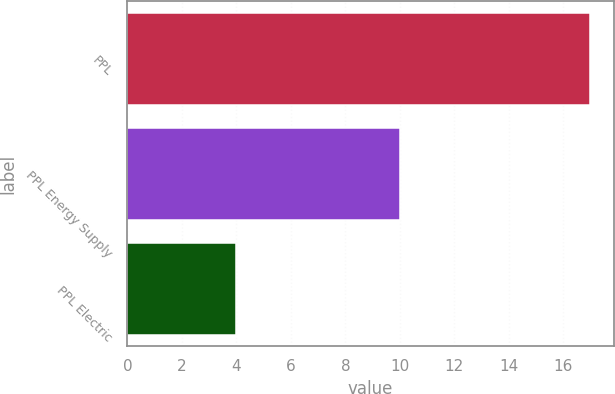Convert chart. <chart><loc_0><loc_0><loc_500><loc_500><bar_chart><fcel>PPL<fcel>PPL Energy Supply<fcel>PPL Electric<nl><fcel>17<fcel>10<fcel>4<nl></chart> 